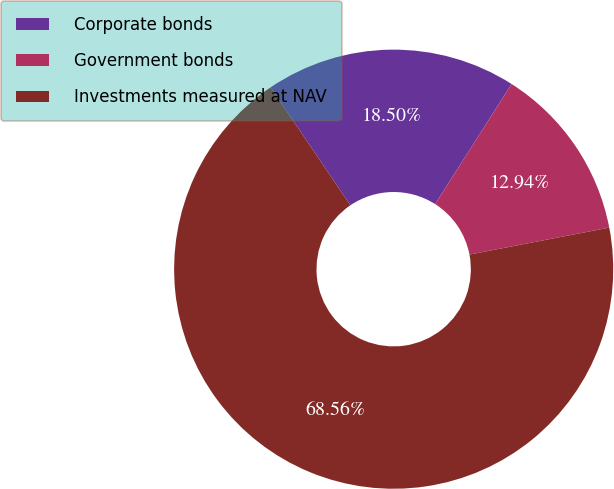<chart> <loc_0><loc_0><loc_500><loc_500><pie_chart><fcel>Corporate bonds<fcel>Government bonds<fcel>Investments measured at NAV<nl><fcel>18.5%<fcel>12.94%<fcel>68.56%<nl></chart> 